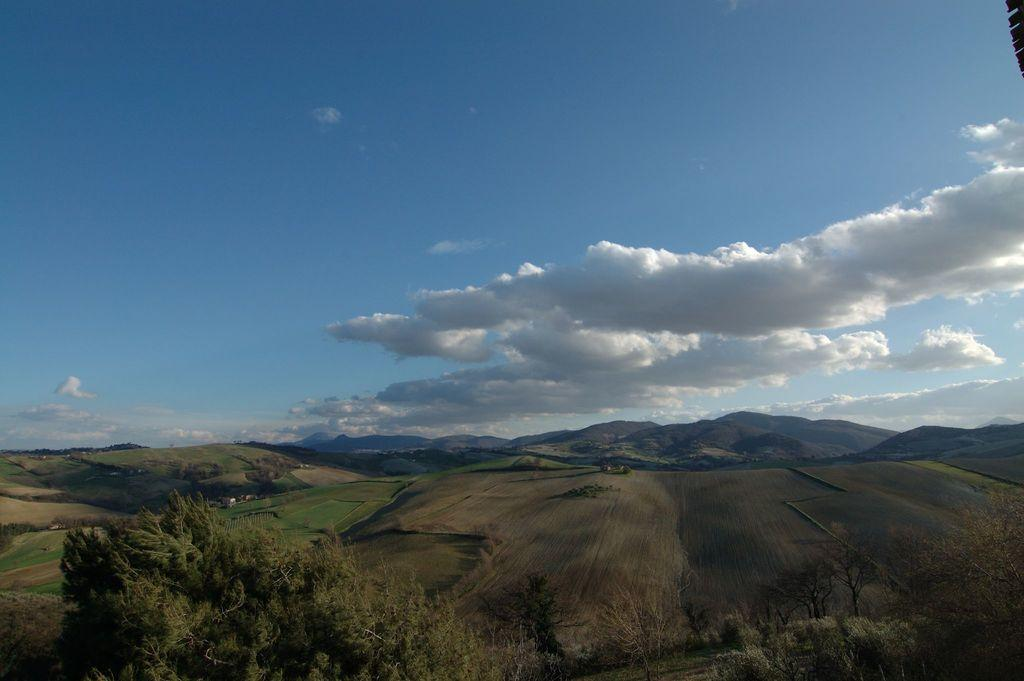What type of landscape is depicted in the image? The image features many mountains. What can be seen on the left side of the image? There is farmland on the left side of the image. What type of vegetation is present at the bottom of the image? There are many trees at the bottom of the image. What is visible at the top of the image? The sky is visible at the top of the image. What can be observed in the sky? Clouds are present in the sky. Can you hear the drum being played by the bat in the image? There is no drum or bat present in the image; it features mountains, farmland, trees, and clouds. 